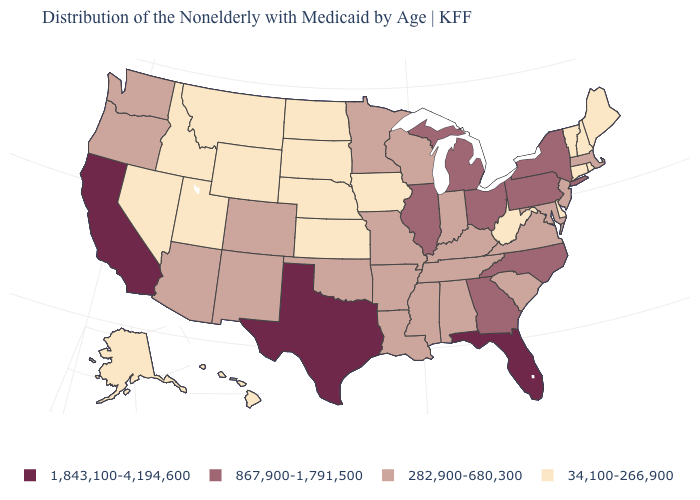How many symbols are there in the legend?
Be succinct. 4. What is the value of Oregon?
Give a very brief answer. 282,900-680,300. Name the states that have a value in the range 34,100-266,900?
Write a very short answer. Alaska, Connecticut, Delaware, Hawaii, Idaho, Iowa, Kansas, Maine, Montana, Nebraska, Nevada, New Hampshire, North Dakota, Rhode Island, South Dakota, Utah, Vermont, West Virginia, Wyoming. How many symbols are there in the legend?
Concise answer only. 4. What is the highest value in the USA?
Keep it brief. 1,843,100-4,194,600. Does the map have missing data?
Quick response, please. No. Name the states that have a value in the range 34,100-266,900?
Quick response, please. Alaska, Connecticut, Delaware, Hawaii, Idaho, Iowa, Kansas, Maine, Montana, Nebraska, Nevada, New Hampshire, North Dakota, Rhode Island, South Dakota, Utah, Vermont, West Virginia, Wyoming. Does South Carolina have a higher value than South Dakota?
Keep it brief. Yes. Among the states that border Florida , does Georgia have the highest value?
Answer briefly. Yes. Name the states that have a value in the range 1,843,100-4,194,600?
Short answer required. California, Florida, Texas. Which states hav the highest value in the Northeast?
Write a very short answer. New York, Pennsylvania. What is the lowest value in the MidWest?
Give a very brief answer. 34,100-266,900. Name the states that have a value in the range 34,100-266,900?
Be succinct. Alaska, Connecticut, Delaware, Hawaii, Idaho, Iowa, Kansas, Maine, Montana, Nebraska, Nevada, New Hampshire, North Dakota, Rhode Island, South Dakota, Utah, Vermont, West Virginia, Wyoming. Name the states that have a value in the range 282,900-680,300?
Keep it brief. Alabama, Arizona, Arkansas, Colorado, Indiana, Kentucky, Louisiana, Maryland, Massachusetts, Minnesota, Mississippi, Missouri, New Jersey, New Mexico, Oklahoma, Oregon, South Carolina, Tennessee, Virginia, Washington, Wisconsin. 